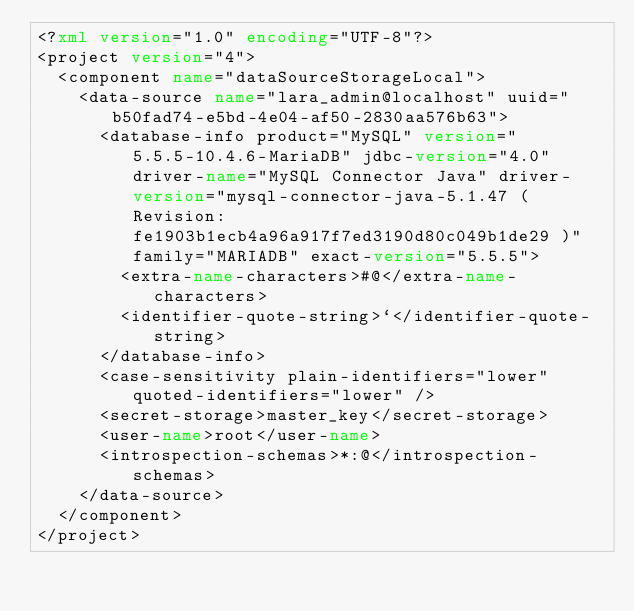<code> <loc_0><loc_0><loc_500><loc_500><_XML_><?xml version="1.0" encoding="UTF-8"?>
<project version="4">
  <component name="dataSourceStorageLocal">
    <data-source name="lara_admin@localhost" uuid="b50fad74-e5bd-4e04-af50-2830aa576b63">
      <database-info product="MySQL" version="5.5.5-10.4.6-MariaDB" jdbc-version="4.0" driver-name="MySQL Connector Java" driver-version="mysql-connector-java-5.1.47 ( Revision: fe1903b1ecb4a96a917f7ed3190d80c049b1de29 )" family="MARIADB" exact-version="5.5.5">
        <extra-name-characters>#@</extra-name-characters>
        <identifier-quote-string>`</identifier-quote-string>
      </database-info>
      <case-sensitivity plain-identifiers="lower" quoted-identifiers="lower" />
      <secret-storage>master_key</secret-storage>
      <user-name>root</user-name>
      <introspection-schemas>*:@</introspection-schemas>
    </data-source>
  </component>
</project></code> 